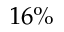Convert formula to latex. <formula><loc_0><loc_0><loc_500><loc_500>1 6 \%</formula> 